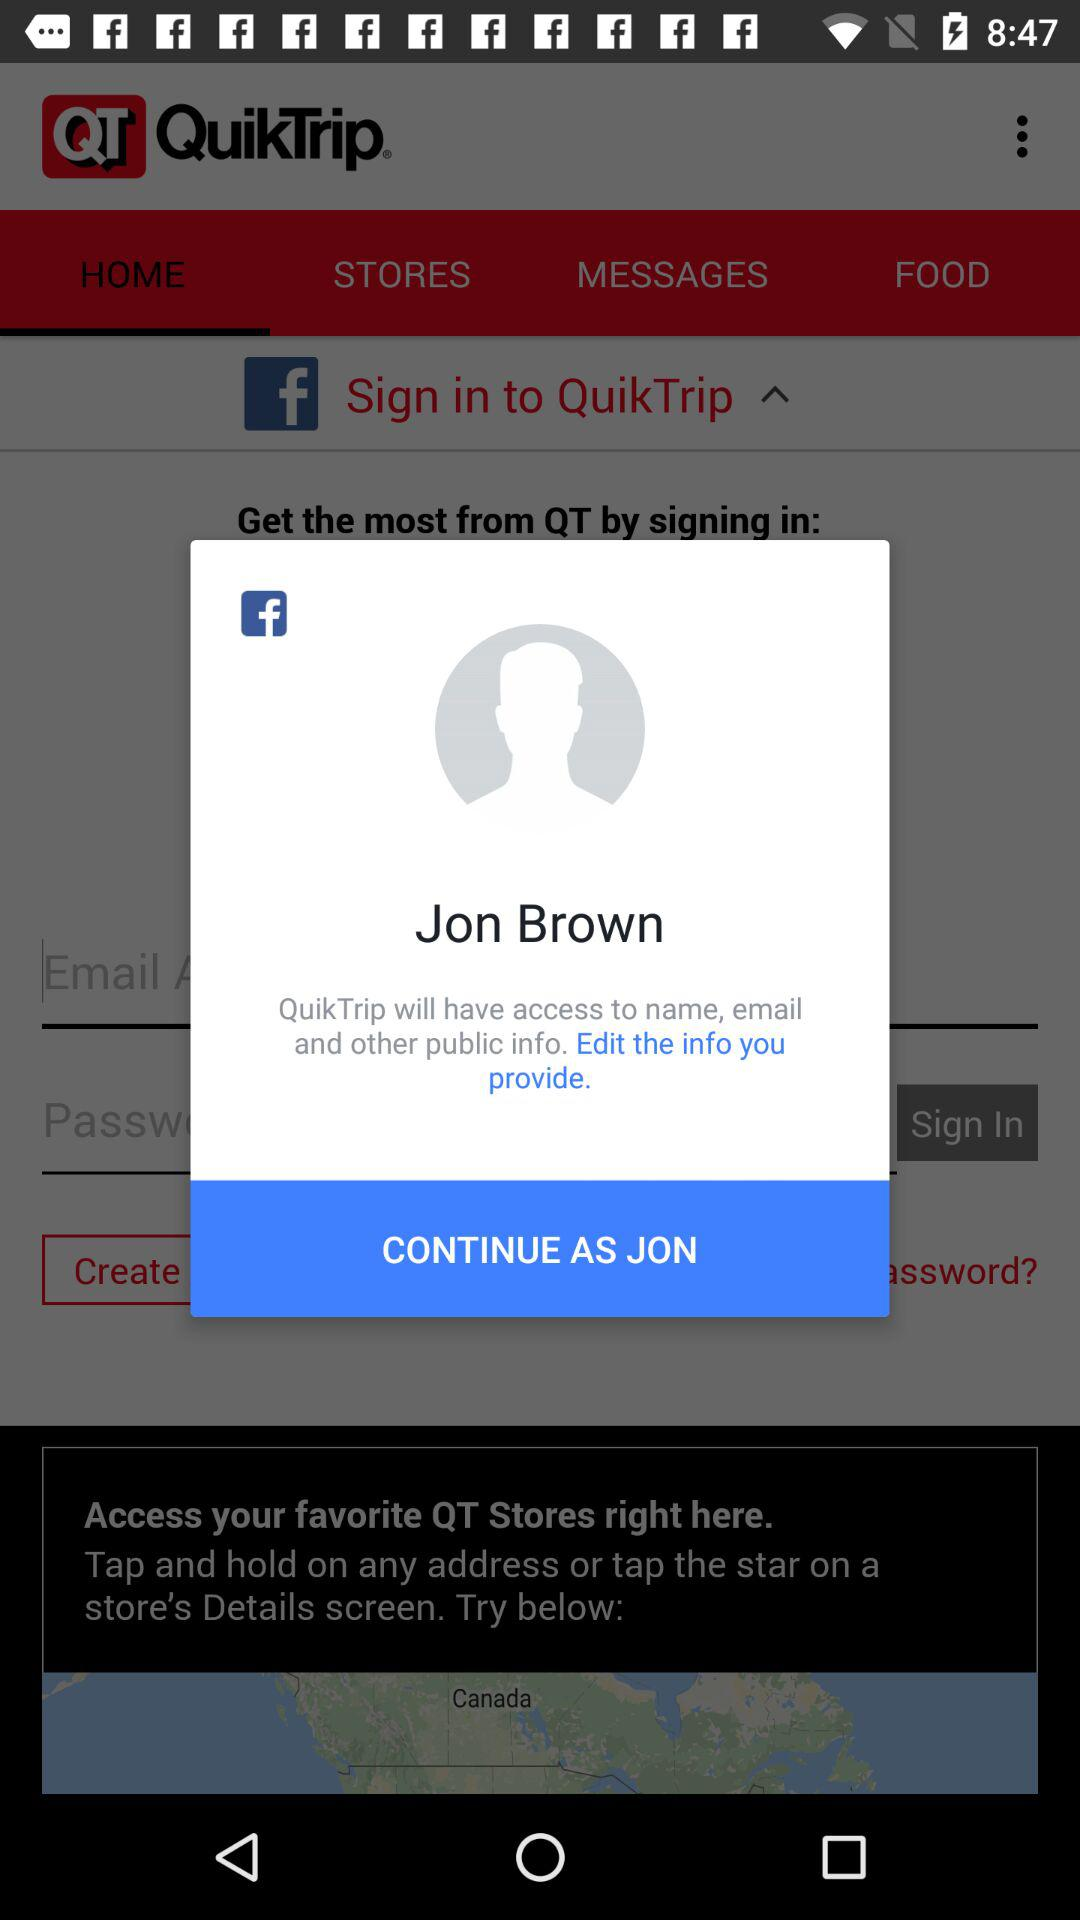What's the name of the user by whom the application can be continued? The name of the user is Jon Brown. 